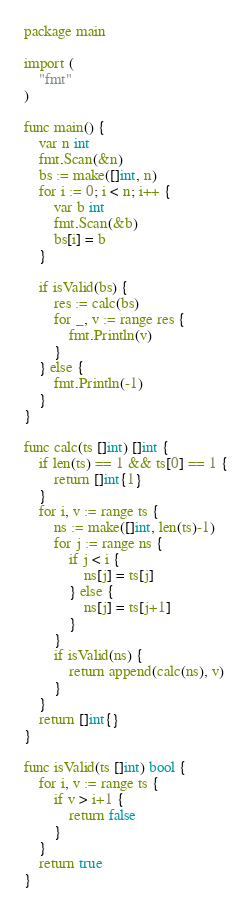<code> <loc_0><loc_0><loc_500><loc_500><_Go_>package main

import (
    "fmt"
)

func main() {
    var n int
    fmt.Scan(&n)
    bs := make([]int, n)
    for i := 0; i < n; i++ {
        var b int
        fmt.Scan(&b)
        bs[i] = b
    }

    if isValid(bs) {
        res := calc(bs)
        for _, v := range res {
            fmt.Println(v)
        }
    } else {
        fmt.Println(-1)
    }
}

func calc(ts []int) []int {
    if len(ts) == 1 && ts[0] == 1 {
        return []int{1}
    }
    for i, v := range ts {
        ns := make([]int, len(ts)-1)
        for j := range ns {
            if j < i {
                ns[j] = ts[j]
            } else {
                ns[j] = ts[j+1]
            }
        }
        if isValid(ns) {
            return append(calc(ns), v)
        }
    }
    return []int{}
}

func isValid(ts []int) bool {
    for i, v := range ts {
        if v > i+1 {
            return false
        }
    }
    return true
}
</code> 